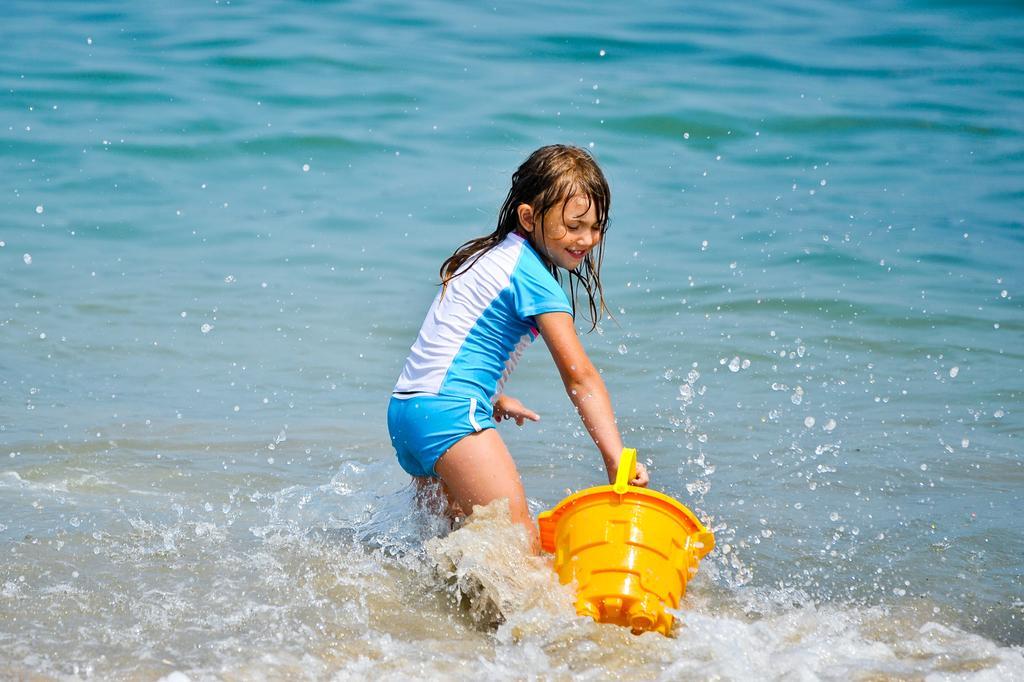Can you describe this image briefly? In this image we can see a girl is holding a bucket in her hand and she is partially in the water. 